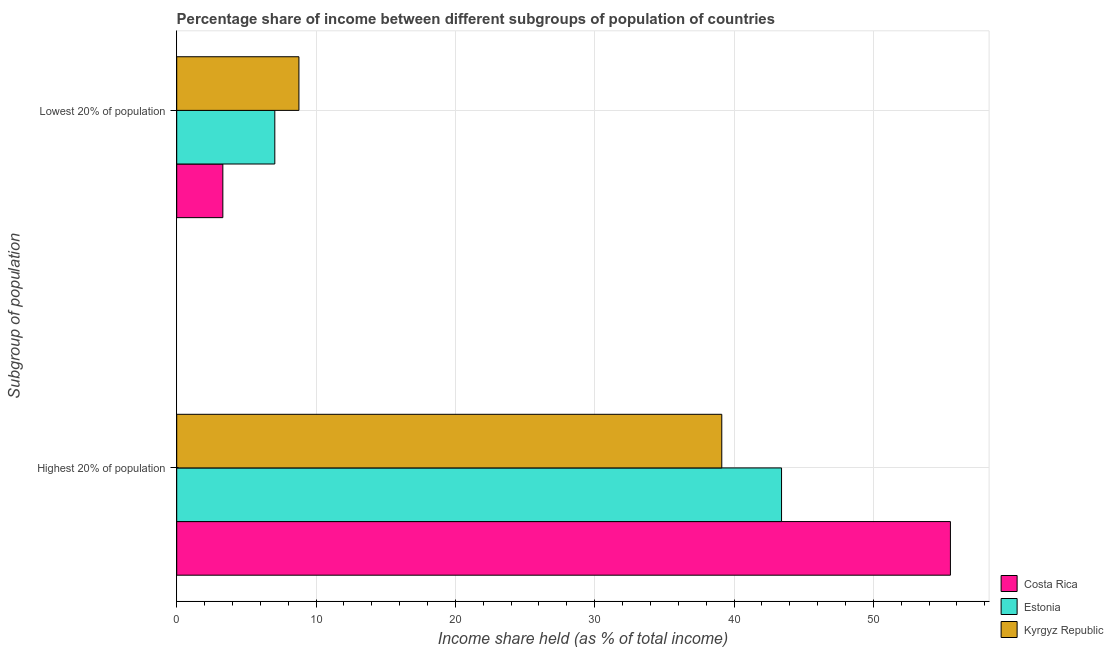How many different coloured bars are there?
Offer a very short reply. 3. Are the number of bars per tick equal to the number of legend labels?
Make the answer very short. Yes. Are the number of bars on each tick of the Y-axis equal?
Provide a succinct answer. Yes. What is the label of the 1st group of bars from the top?
Provide a short and direct response. Lowest 20% of population. What is the income share held by highest 20% of the population in Estonia?
Your answer should be compact. 43.41. Across all countries, what is the maximum income share held by lowest 20% of the population?
Provide a succinct answer. 8.77. Across all countries, what is the minimum income share held by highest 20% of the population?
Offer a terse response. 39.12. In which country was the income share held by lowest 20% of the population maximum?
Provide a short and direct response. Kyrgyz Republic. In which country was the income share held by highest 20% of the population minimum?
Ensure brevity in your answer.  Kyrgyz Republic. What is the total income share held by highest 20% of the population in the graph?
Your answer should be compact. 138.06. What is the difference between the income share held by lowest 20% of the population in Costa Rica and that in Estonia?
Provide a short and direct response. -3.73. What is the difference between the income share held by lowest 20% of the population in Kyrgyz Republic and the income share held by highest 20% of the population in Costa Rica?
Provide a short and direct response. -46.76. What is the average income share held by lowest 20% of the population per country?
Offer a very short reply. 6.37. What is the difference between the income share held by lowest 20% of the population and income share held by highest 20% of the population in Costa Rica?
Your response must be concise. -52.22. What is the ratio of the income share held by lowest 20% of the population in Estonia to that in Kyrgyz Republic?
Your answer should be compact. 0.8. Is the income share held by lowest 20% of the population in Estonia less than that in Costa Rica?
Give a very brief answer. No. In how many countries, is the income share held by lowest 20% of the population greater than the average income share held by lowest 20% of the population taken over all countries?
Give a very brief answer. 2. What does the 1st bar from the top in Lowest 20% of population represents?
Offer a terse response. Kyrgyz Republic. What does the 3rd bar from the bottom in Highest 20% of population represents?
Provide a short and direct response. Kyrgyz Republic. Are all the bars in the graph horizontal?
Provide a succinct answer. Yes. How many legend labels are there?
Make the answer very short. 3. What is the title of the graph?
Make the answer very short. Percentage share of income between different subgroups of population of countries. Does "Myanmar" appear as one of the legend labels in the graph?
Give a very brief answer. No. What is the label or title of the X-axis?
Offer a very short reply. Income share held (as % of total income). What is the label or title of the Y-axis?
Your answer should be compact. Subgroup of population. What is the Income share held (as % of total income) of Costa Rica in Highest 20% of population?
Keep it short and to the point. 55.53. What is the Income share held (as % of total income) in Estonia in Highest 20% of population?
Your answer should be compact. 43.41. What is the Income share held (as % of total income) of Kyrgyz Republic in Highest 20% of population?
Offer a very short reply. 39.12. What is the Income share held (as % of total income) in Costa Rica in Lowest 20% of population?
Give a very brief answer. 3.31. What is the Income share held (as % of total income) in Estonia in Lowest 20% of population?
Provide a short and direct response. 7.04. What is the Income share held (as % of total income) of Kyrgyz Republic in Lowest 20% of population?
Offer a very short reply. 8.77. Across all Subgroup of population, what is the maximum Income share held (as % of total income) of Costa Rica?
Provide a short and direct response. 55.53. Across all Subgroup of population, what is the maximum Income share held (as % of total income) of Estonia?
Your answer should be compact. 43.41. Across all Subgroup of population, what is the maximum Income share held (as % of total income) in Kyrgyz Republic?
Provide a succinct answer. 39.12. Across all Subgroup of population, what is the minimum Income share held (as % of total income) in Costa Rica?
Offer a very short reply. 3.31. Across all Subgroup of population, what is the minimum Income share held (as % of total income) in Estonia?
Offer a very short reply. 7.04. Across all Subgroup of population, what is the minimum Income share held (as % of total income) of Kyrgyz Republic?
Provide a short and direct response. 8.77. What is the total Income share held (as % of total income) in Costa Rica in the graph?
Your answer should be very brief. 58.84. What is the total Income share held (as % of total income) in Estonia in the graph?
Give a very brief answer. 50.45. What is the total Income share held (as % of total income) of Kyrgyz Republic in the graph?
Provide a short and direct response. 47.89. What is the difference between the Income share held (as % of total income) in Costa Rica in Highest 20% of population and that in Lowest 20% of population?
Provide a succinct answer. 52.22. What is the difference between the Income share held (as % of total income) of Estonia in Highest 20% of population and that in Lowest 20% of population?
Offer a very short reply. 36.37. What is the difference between the Income share held (as % of total income) of Kyrgyz Republic in Highest 20% of population and that in Lowest 20% of population?
Your answer should be very brief. 30.35. What is the difference between the Income share held (as % of total income) of Costa Rica in Highest 20% of population and the Income share held (as % of total income) of Estonia in Lowest 20% of population?
Your response must be concise. 48.49. What is the difference between the Income share held (as % of total income) in Costa Rica in Highest 20% of population and the Income share held (as % of total income) in Kyrgyz Republic in Lowest 20% of population?
Provide a succinct answer. 46.76. What is the difference between the Income share held (as % of total income) of Estonia in Highest 20% of population and the Income share held (as % of total income) of Kyrgyz Republic in Lowest 20% of population?
Offer a very short reply. 34.64. What is the average Income share held (as % of total income) in Costa Rica per Subgroup of population?
Provide a succinct answer. 29.42. What is the average Income share held (as % of total income) of Estonia per Subgroup of population?
Offer a very short reply. 25.23. What is the average Income share held (as % of total income) of Kyrgyz Republic per Subgroup of population?
Your answer should be very brief. 23.95. What is the difference between the Income share held (as % of total income) in Costa Rica and Income share held (as % of total income) in Estonia in Highest 20% of population?
Provide a succinct answer. 12.12. What is the difference between the Income share held (as % of total income) of Costa Rica and Income share held (as % of total income) of Kyrgyz Republic in Highest 20% of population?
Your answer should be compact. 16.41. What is the difference between the Income share held (as % of total income) of Estonia and Income share held (as % of total income) of Kyrgyz Republic in Highest 20% of population?
Keep it short and to the point. 4.29. What is the difference between the Income share held (as % of total income) in Costa Rica and Income share held (as % of total income) in Estonia in Lowest 20% of population?
Your answer should be very brief. -3.73. What is the difference between the Income share held (as % of total income) in Costa Rica and Income share held (as % of total income) in Kyrgyz Republic in Lowest 20% of population?
Provide a short and direct response. -5.46. What is the difference between the Income share held (as % of total income) in Estonia and Income share held (as % of total income) in Kyrgyz Republic in Lowest 20% of population?
Keep it short and to the point. -1.73. What is the ratio of the Income share held (as % of total income) of Costa Rica in Highest 20% of population to that in Lowest 20% of population?
Ensure brevity in your answer.  16.78. What is the ratio of the Income share held (as % of total income) of Estonia in Highest 20% of population to that in Lowest 20% of population?
Make the answer very short. 6.17. What is the ratio of the Income share held (as % of total income) in Kyrgyz Republic in Highest 20% of population to that in Lowest 20% of population?
Provide a short and direct response. 4.46. What is the difference between the highest and the second highest Income share held (as % of total income) in Costa Rica?
Provide a succinct answer. 52.22. What is the difference between the highest and the second highest Income share held (as % of total income) of Estonia?
Offer a very short reply. 36.37. What is the difference between the highest and the second highest Income share held (as % of total income) of Kyrgyz Republic?
Keep it short and to the point. 30.35. What is the difference between the highest and the lowest Income share held (as % of total income) of Costa Rica?
Ensure brevity in your answer.  52.22. What is the difference between the highest and the lowest Income share held (as % of total income) in Estonia?
Give a very brief answer. 36.37. What is the difference between the highest and the lowest Income share held (as % of total income) of Kyrgyz Republic?
Ensure brevity in your answer.  30.35. 